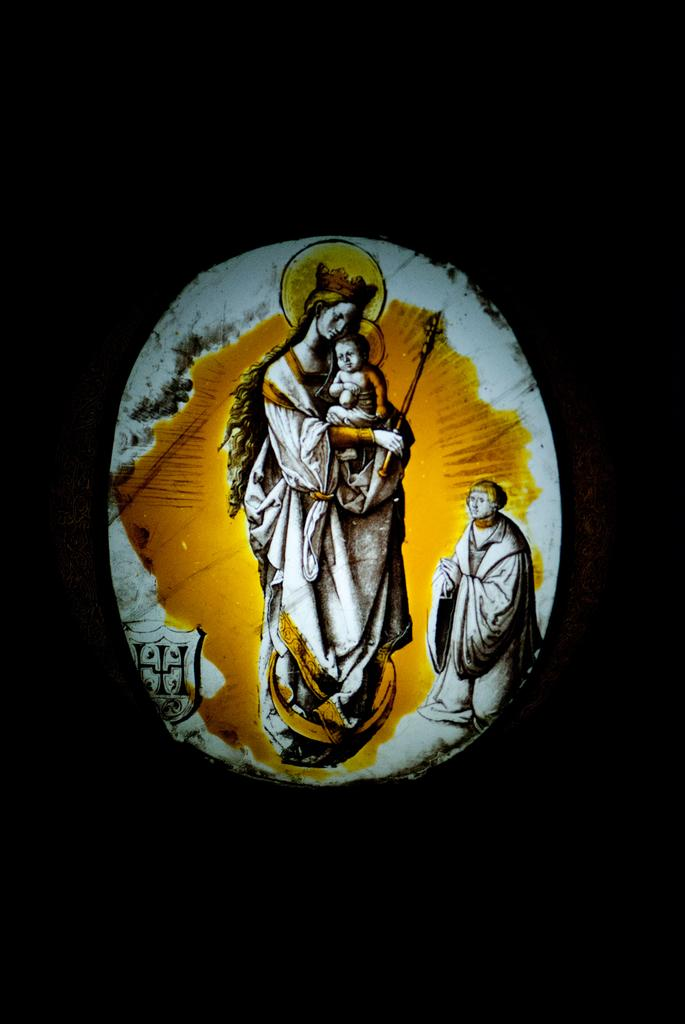What is depicted in the image? There are images of people in the image. What color is the background of the image? The background of the image is black. Can you see any fog in the image? There is no fog present in the image; the background is black. What type of tank is visible in the image? There is no tank present in the image; it only features images of people with a black background. 